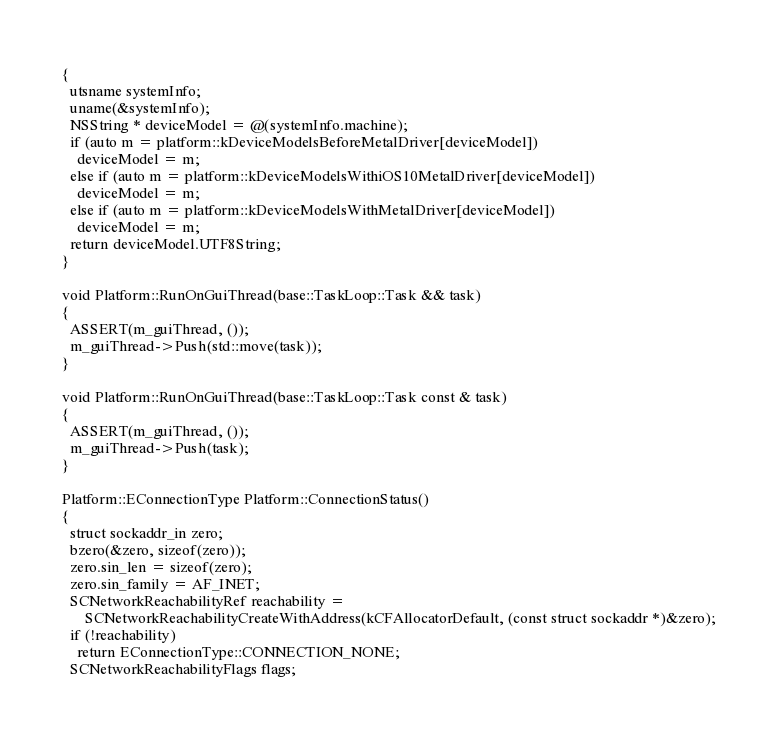Convert code to text. <code><loc_0><loc_0><loc_500><loc_500><_ObjectiveC_>{
  utsname systemInfo;
  uname(&systemInfo);
  NSString * deviceModel = @(systemInfo.machine);
  if (auto m = platform::kDeviceModelsBeforeMetalDriver[deviceModel])
    deviceModel = m;
  else if (auto m = platform::kDeviceModelsWithiOS10MetalDriver[deviceModel])
    deviceModel = m;
  else if (auto m = platform::kDeviceModelsWithMetalDriver[deviceModel])
    deviceModel = m;
  return deviceModel.UTF8String;
}

void Platform::RunOnGuiThread(base::TaskLoop::Task && task)
{
  ASSERT(m_guiThread, ());
  m_guiThread->Push(std::move(task));
}

void Platform::RunOnGuiThread(base::TaskLoop::Task const & task)
{
  ASSERT(m_guiThread, ());
  m_guiThread->Push(task);
}

Platform::EConnectionType Platform::ConnectionStatus()
{
  struct sockaddr_in zero;
  bzero(&zero, sizeof(zero));
  zero.sin_len = sizeof(zero);
  zero.sin_family = AF_INET;
  SCNetworkReachabilityRef reachability =
      SCNetworkReachabilityCreateWithAddress(kCFAllocatorDefault, (const struct sockaddr *)&zero);
  if (!reachability)
    return EConnectionType::CONNECTION_NONE;
  SCNetworkReachabilityFlags flags;</code> 